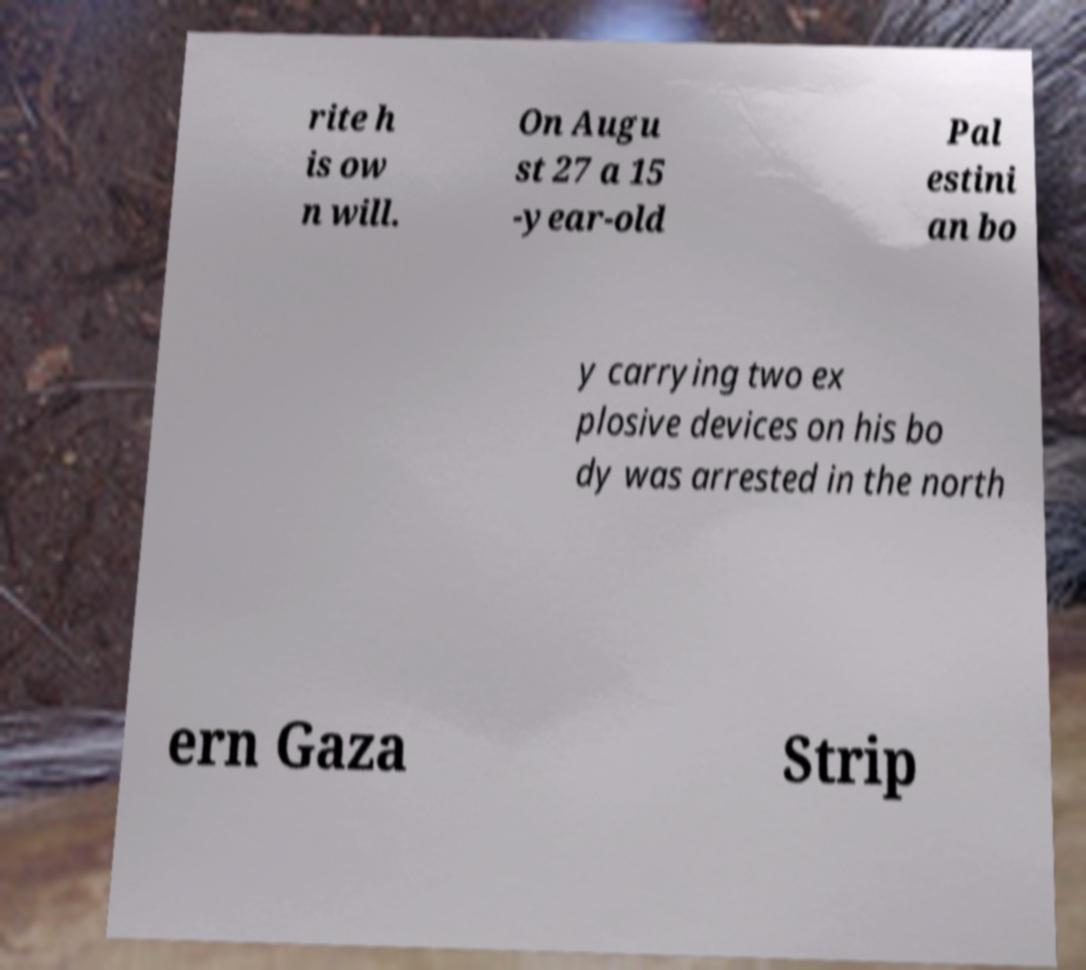Could you assist in decoding the text presented in this image and type it out clearly? rite h is ow n will. On Augu st 27 a 15 -year-old Pal estini an bo y carrying two ex plosive devices on his bo dy was arrested in the north ern Gaza Strip 